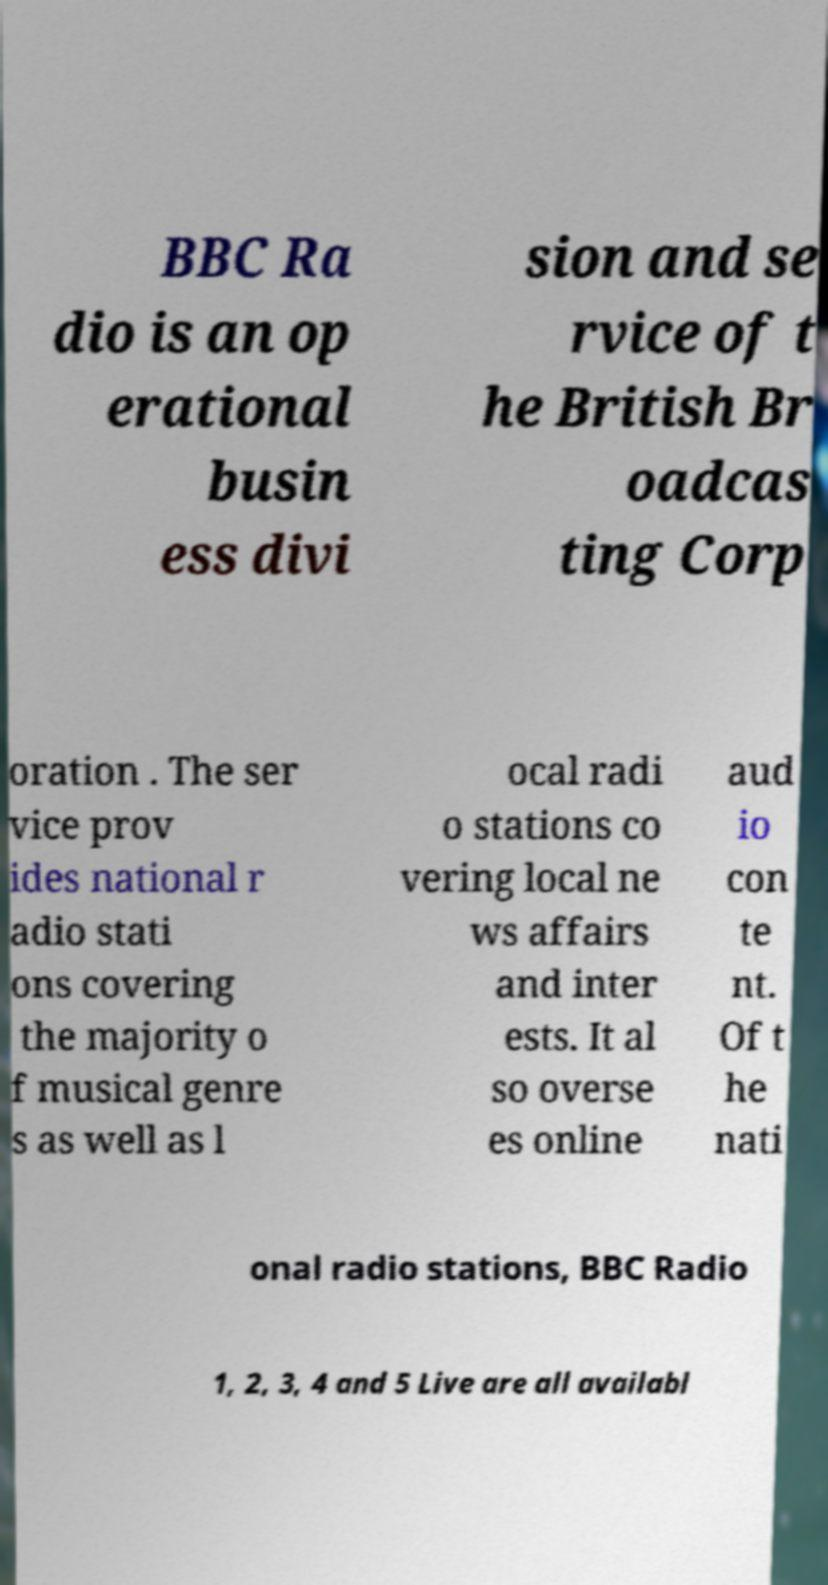There's text embedded in this image that I need extracted. Can you transcribe it verbatim? BBC Ra dio is an op erational busin ess divi sion and se rvice of t he British Br oadcas ting Corp oration . The ser vice prov ides national r adio stati ons covering the majority o f musical genre s as well as l ocal radi o stations co vering local ne ws affairs and inter ests. It al so overse es online aud io con te nt. Of t he nati onal radio stations, BBC Radio 1, 2, 3, 4 and 5 Live are all availabl 